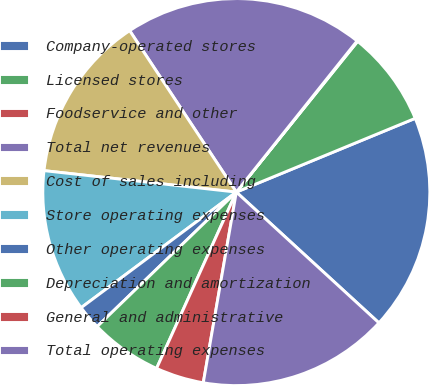<chart> <loc_0><loc_0><loc_500><loc_500><pie_chart><fcel>Company-operated stores<fcel>Licensed stores<fcel>Foodservice and other<fcel>Total net revenues<fcel>Cost of sales including<fcel>Store operating expenses<fcel>Other operating expenses<fcel>Depreciation and amortization<fcel>General and administrative<fcel>Total operating expenses<nl><fcel>18.04%<fcel>7.99%<fcel>0.06%<fcel>20.02%<fcel>13.94%<fcel>11.96%<fcel>2.04%<fcel>6.01%<fcel>4.03%<fcel>15.92%<nl></chart> 